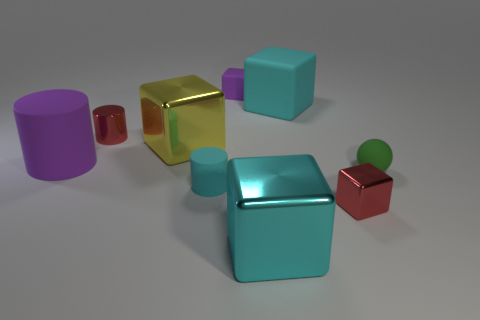How many red things are tiny cubes or matte cubes?
Your answer should be very brief. 1. Are any small red cylinders visible?
Provide a succinct answer. Yes. Is there a red thing that is in front of the tiny red metallic object in front of the purple rubber thing that is on the left side of the tiny purple cube?
Your response must be concise. No. Is there any other thing that is the same size as the purple matte cylinder?
Make the answer very short. Yes. There is a green matte object; is it the same shape as the big shiny object that is behind the tiny red metal cube?
Provide a succinct answer. No. There is a small cube on the right side of the big block that is on the right side of the large cyan thing in front of the yellow object; what is its color?
Your answer should be very brief. Red. How many things are either red metallic objects that are in front of the small cyan cylinder or tiny shiny objects that are on the left side of the tiny red block?
Ensure brevity in your answer.  2. How many other things are there of the same color as the small matte block?
Your answer should be very brief. 1. There is a purple thing behind the tiny red metal cylinder; is its shape the same as the big purple thing?
Provide a succinct answer. No. Is the number of matte blocks in front of the yellow block less than the number of purple cylinders?
Keep it short and to the point. Yes. 